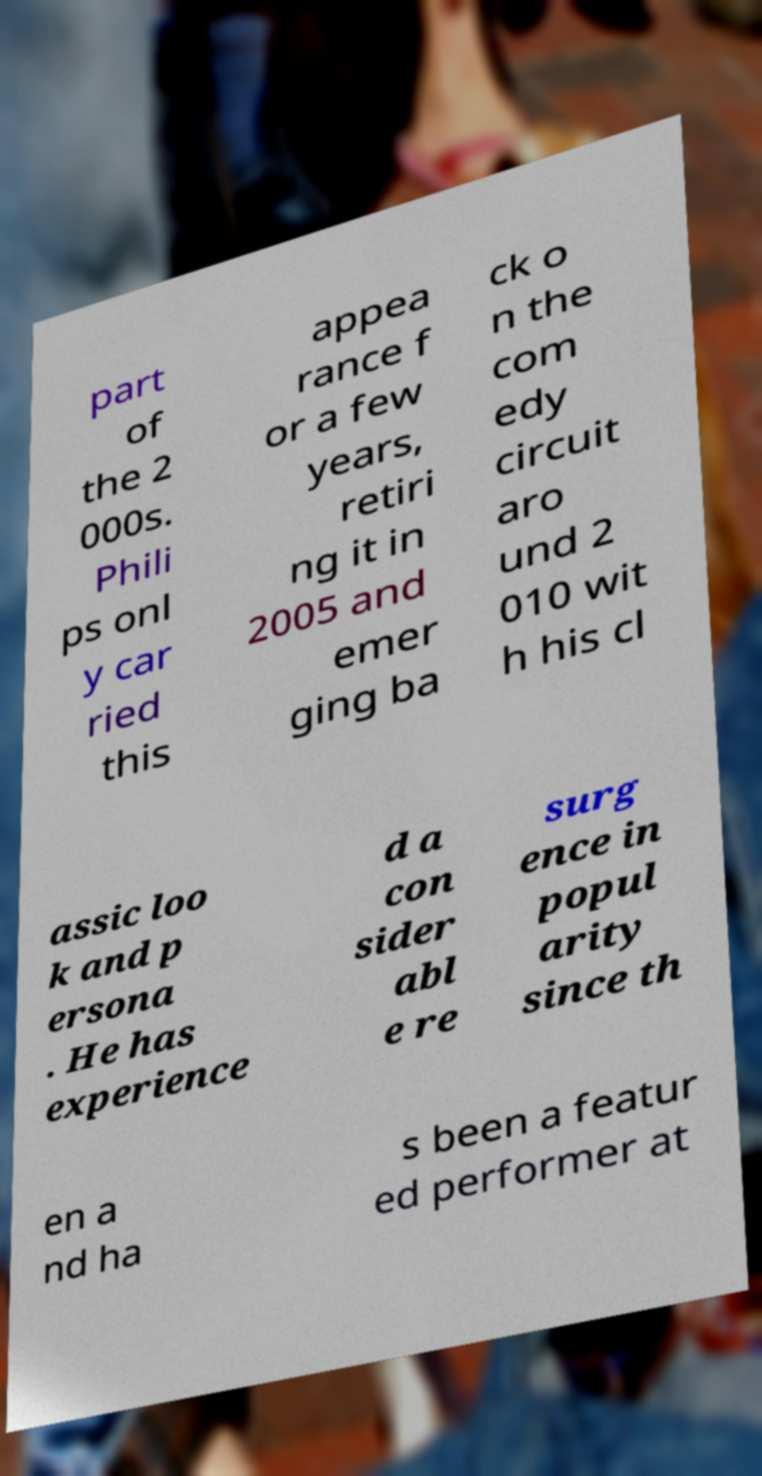Can you accurately transcribe the text from the provided image for me? part of the 2 000s. Phili ps onl y car ried this appea rance f or a few years, retiri ng it in 2005 and emer ging ba ck o n the com edy circuit aro und 2 010 wit h his cl assic loo k and p ersona . He has experience d a con sider abl e re surg ence in popul arity since th en a nd ha s been a featur ed performer at 